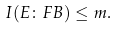<formula> <loc_0><loc_0><loc_500><loc_500>I ( E \colon F B ) \leq m .</formula> 